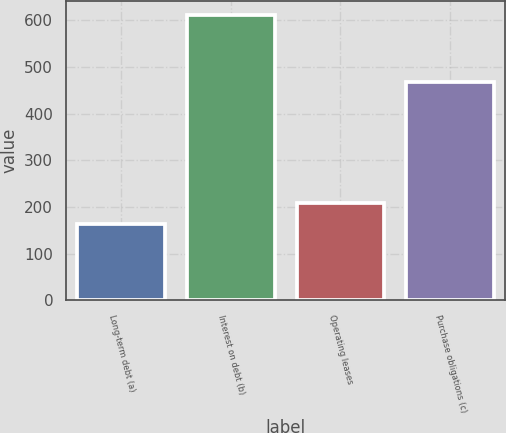<chart> <loc_0><loc_0><loc_500><loc_500><bar_chart><fcel>Long-term debt (a)<fcel>Interest on debt (b)<fcel>Operating leases<fcel>Purchase obligations (c)<nl><fcel>163<fcel>611<fcel>207.8<fcel>468<nl></chart> 